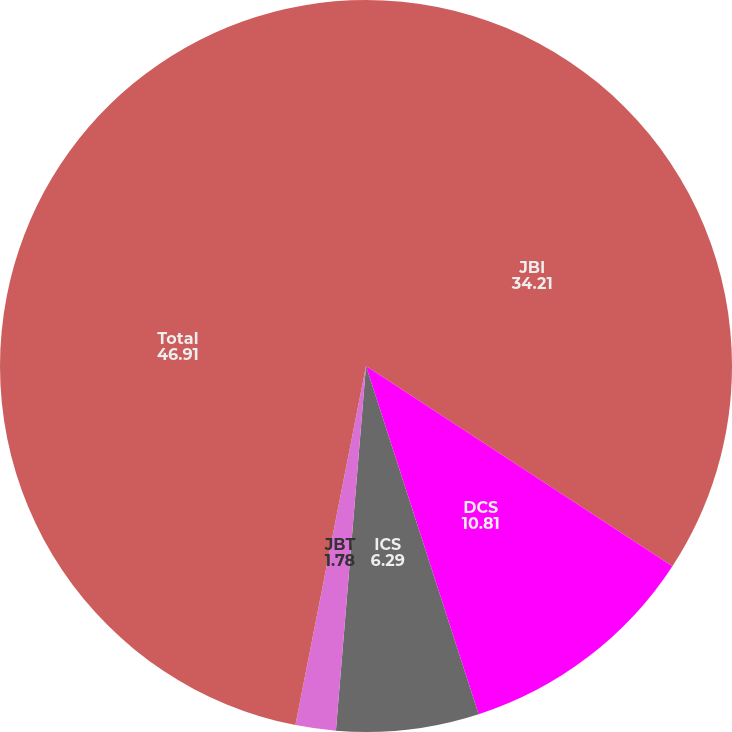<chart> <loc_0><loc_0><loc_500><loc_500><pie_chart><fcel>JBI<fcel>DCS<fcel>ICS<fcel>JBT<fcel>Total<nl><fcel>34.21%<fcel>10.81%<fcel>6.29%<fcel>1.78%<fcel>46.91%<nl></chart> 